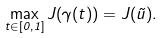Convert formula to latex. <formula><loc_0><loc_0><loc_500><loc_500>\max _ { t \in [ 0 , 1 ] } J ( \gamma ( t ) ) = J ( \tilde { u } ) .</formula> 